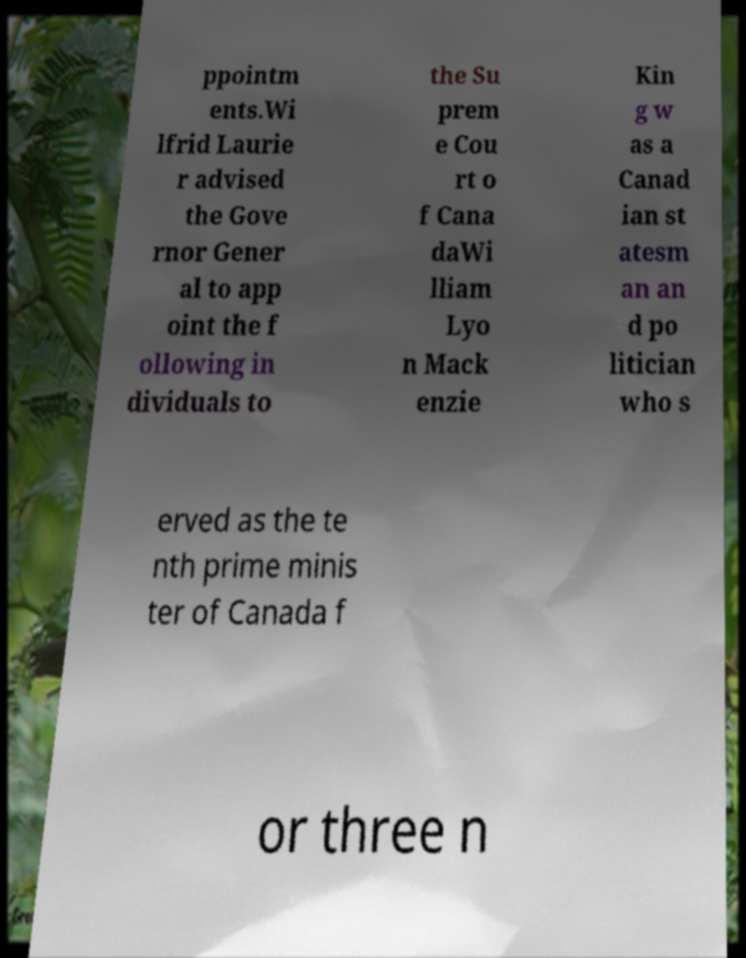Can you accurately transcribe the text from the provided image for me? ppointm ents.Wi lfrid Laurie r advised the Gove rnor Gener al to app oint the f ollowing in dividuals to the Su prem e Cou rt o f Cana daWi lliam Lyo n Mack enzie Kin g w as a Canad ian st atesm an an d po litician who s erved as the te nth prime minis ter of Canada f or three n 